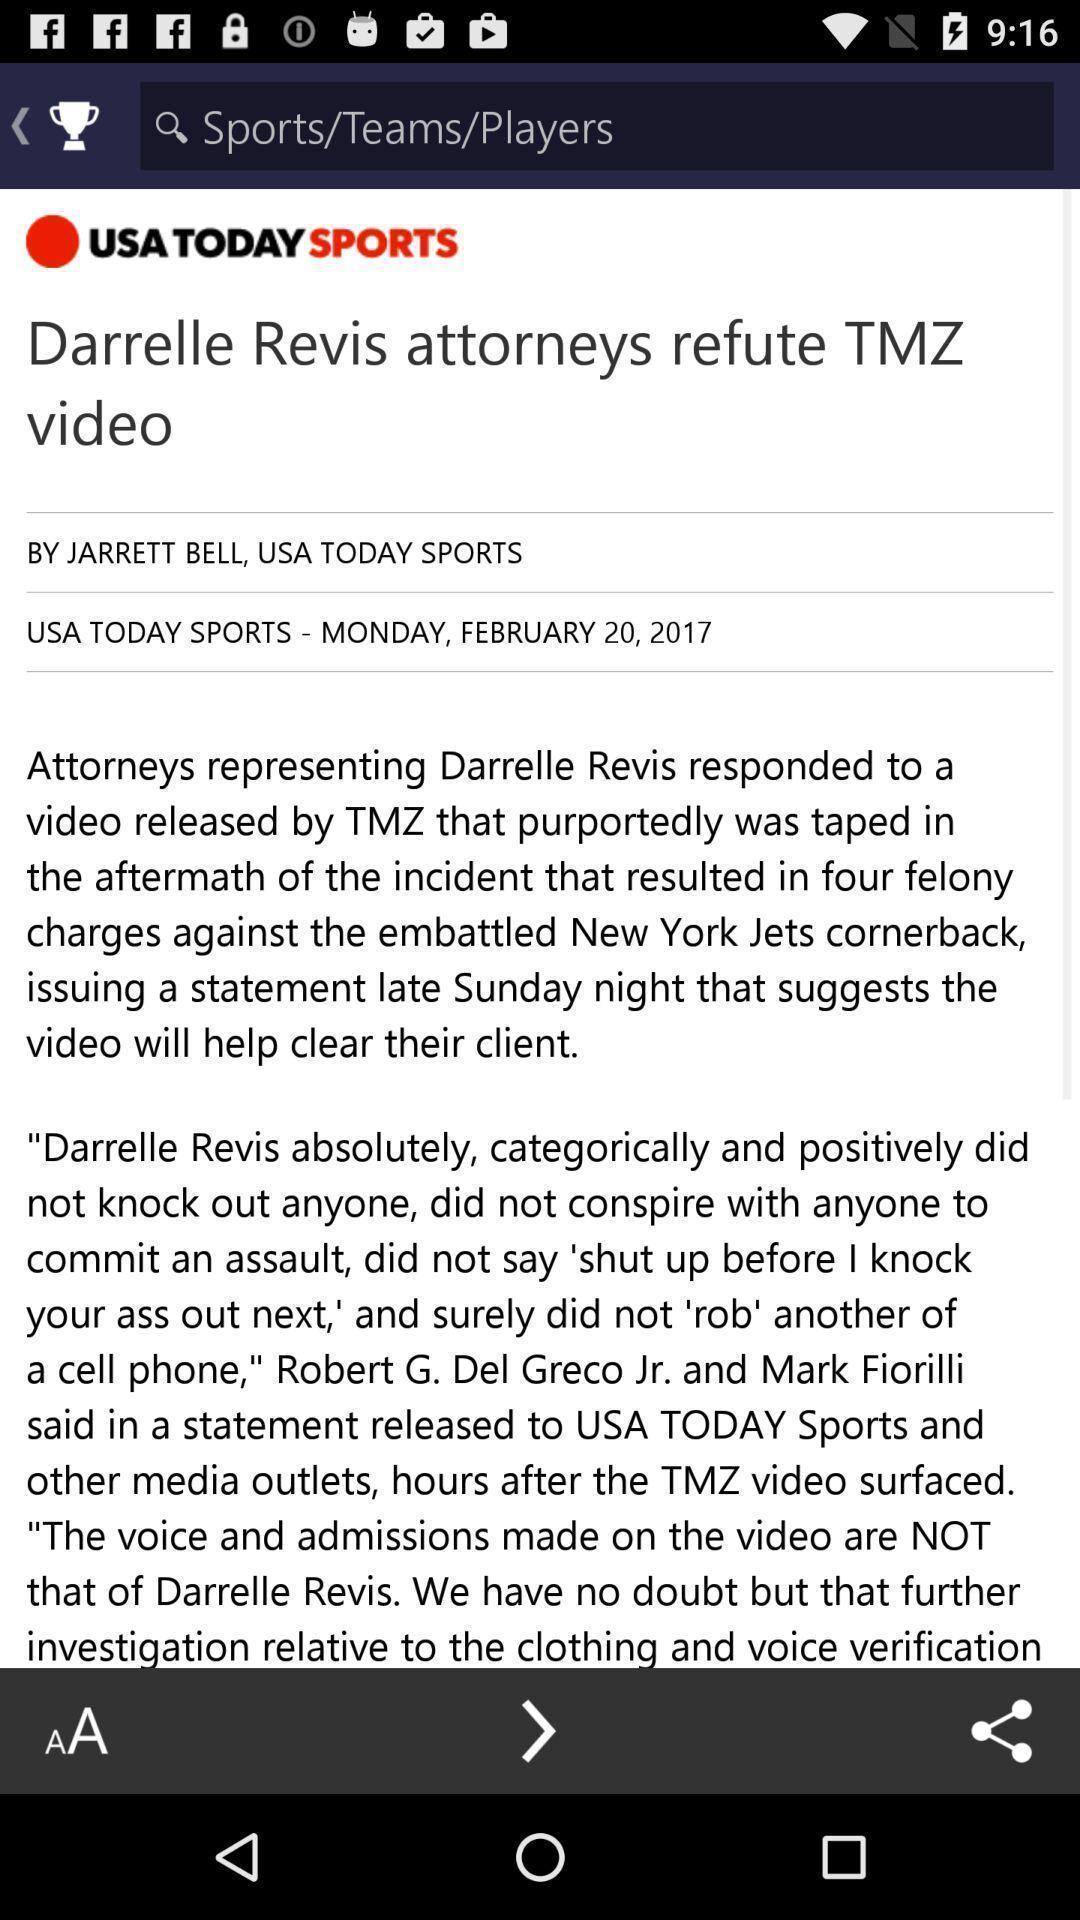Summarize the information in this screenshot. Screen page of a sports app. 